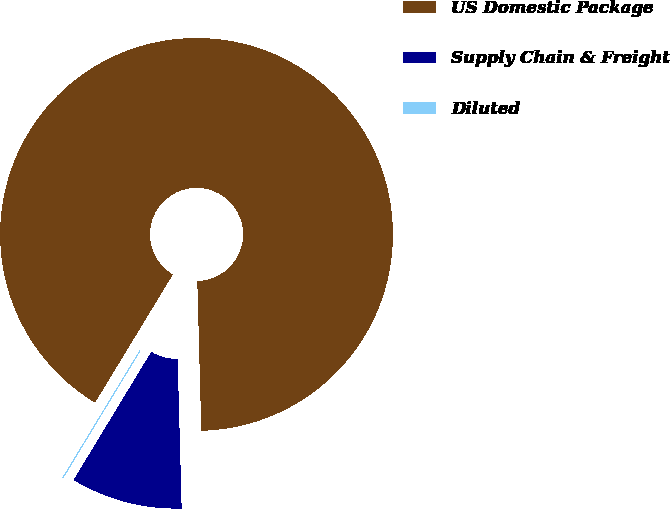Convert chart. <chart><loc_0><loc_0><loc_500><loc_500><pie_chart><fcel>US Domestic Package<fcel>Supply Chain & Freight<fcel>Diluted<nl><fcel>90.89%<fcel>9.1%<fcel>0.01%<nl></chart> 